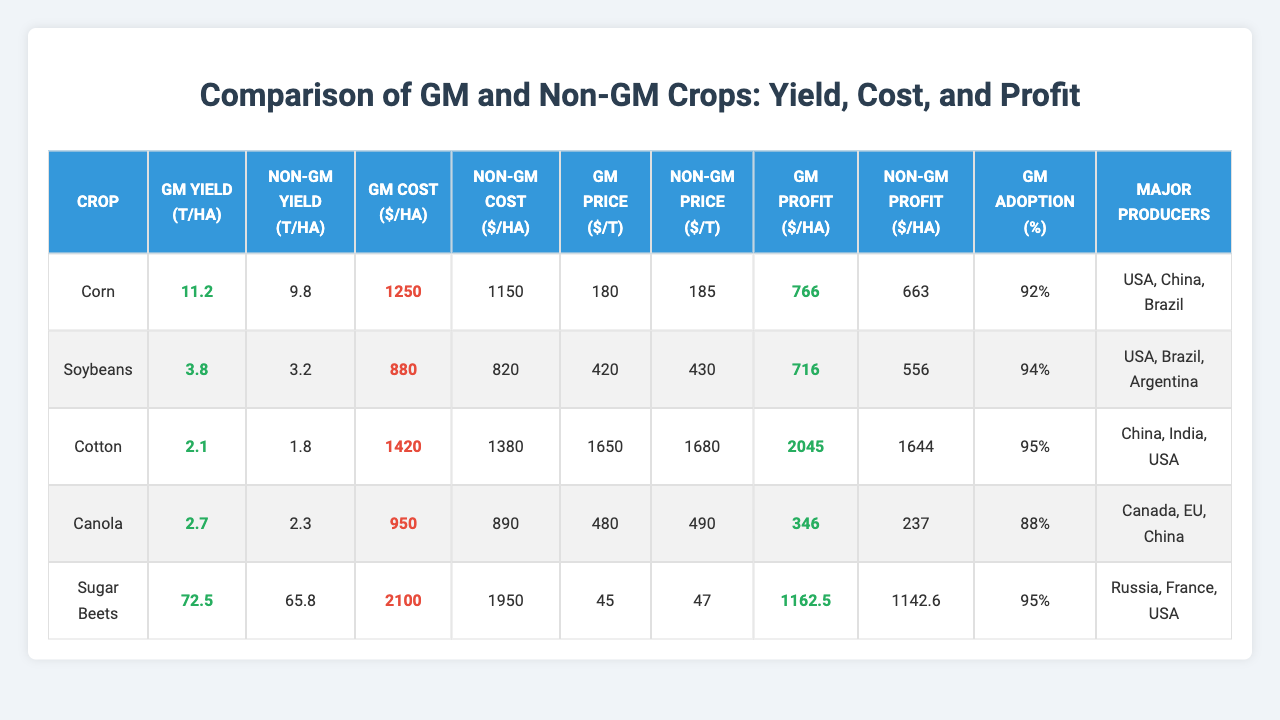What is the yield difference for Corn between GM and Non-GM crops? The yield for GM Corn is 11.2 tons per hectare, while Non-GM is 9.8 tons per hectare. The difference is 11.2 - 9.8 = 1.4 tons per hectare.
Answer: 1.4 tons per hectare Which crop has the highest production cost for GM crops? By analyzing the production costs, GM Sugar Beets have the highest cost at 2100 USD per hectare compared to other GM crops.
Answer: Sugar Beets Is the market price for Non-GM Canola higher than that for GM Canola? The Non-GM market price for Canola is 490 USD per ton, while the GM price is 480 USD per ton. Thus, the Non-GM price is higher.
Answer: Yes What is the profit difference for Cotton between GM and Non-GM crops? The profit for GM Cotton is 2045 USD per hectare, while Non-GM is 1644 USD per hectare. The difference is 2045 - 1644 = 401 USD per hectare.
Answer: 401 USD per hectare Which crop's GM yield has a higher profit per hectare, Corn or Soybeans? GM Corn has a profit of 766 USD per hectare, while GM Soybeans has a profit of 716 USD per hectare. Therefore, GM Corn has a higher profit.
Answer: Corn Calculate the average GM yield for the given crops. The GM yields are 11.2, 3.8, 2.1, 2.7, and 72.5 tons per hectare. The sum is 11.2 + 3.8 + 2.1 + 2.7 + 72.5 = 92.3 tons. There are 5 crops, so the average is 92.3 / 5 = 18.46 tons per hectare.
Answer: 18.46 tons per hectare Are GM crops generally more profitable than Non-GM crops? By comparing the profits, GM crops yield higher profits in Corn, Soybeans, Cotton, and Sugar Beets while Non-GM is higher only in Canola. Therefore, it leans towards GM crops being more profitable.
Answer: Generally Yes Which non-GM crop has the highest profit? The highest profit for Non-GM crops is in Non-GM Cotton with a profit of 1644 USD per hectare.
Answer: Cotton What percentage of GM crops are adopted for Soybeans? The GM adoption rate for Soybeans is 94%, as listed in the table.
Answer: 94% Which crop has the highest yield for Non-GM and how much is it? The highest yield for Non-GM crops is in Non-GM Sugar Beets at 65.8 tons per hectare.
Answer: Sugar Beets 